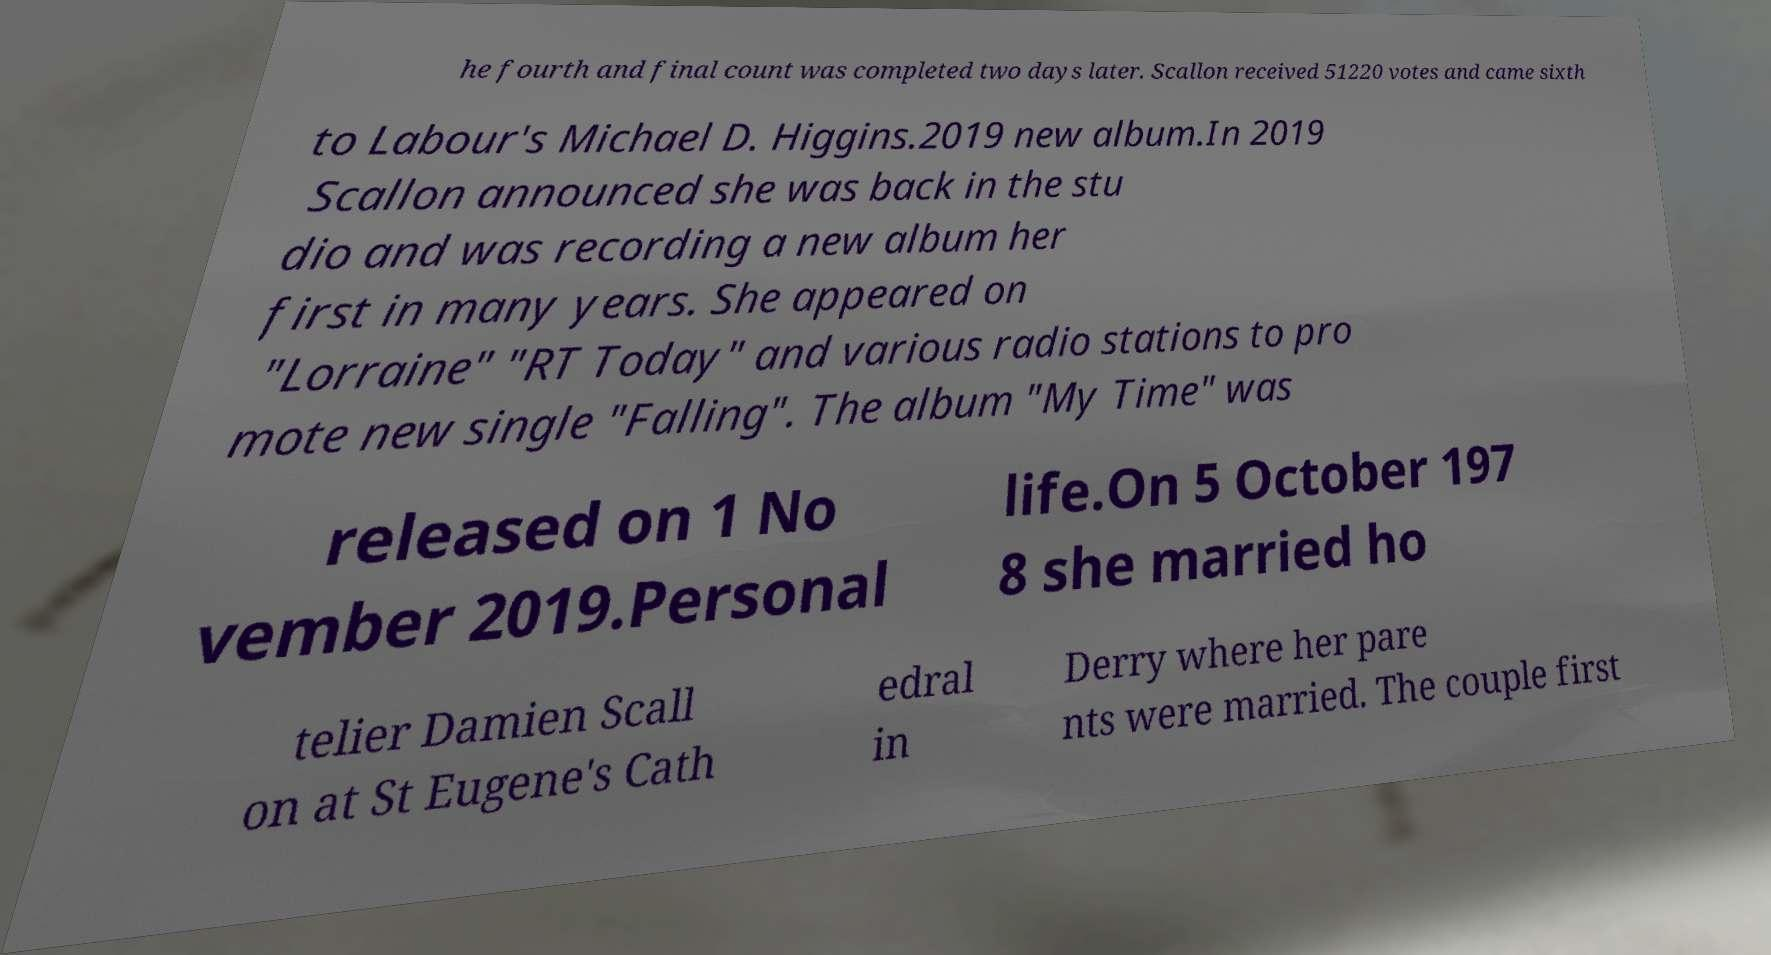Can you accurately transcribe the text from the provided image for me? he fourth and final count was completed two days later. Scallon received 51220 votes and came sixth to Labour's Michael D. Higgins.2019 new album.In 2019 Scallon announced she was back in the stu dio and was recording a new album her first in many years. She appeared on "Lorraine" "RT Today" and various radio stations to pro mote new single "Falling". The album "My Time" was released on 1 No vember 2019.Personal life.On 5 October 197 8 she married ho telier Damien Scall on at St Eugene's Cath edral in Derry where her pare nts were married. The couple first 